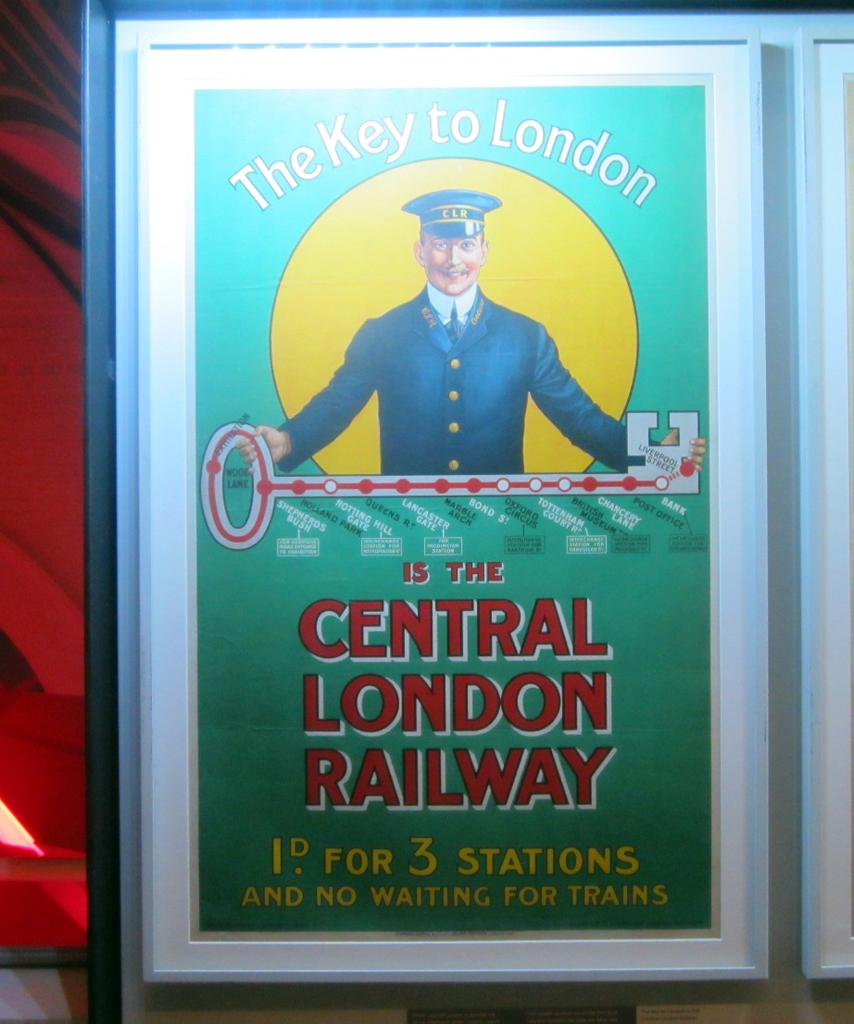<image>
Present a compact description of the photo's key features. A framed poster for the Central London Railway. 